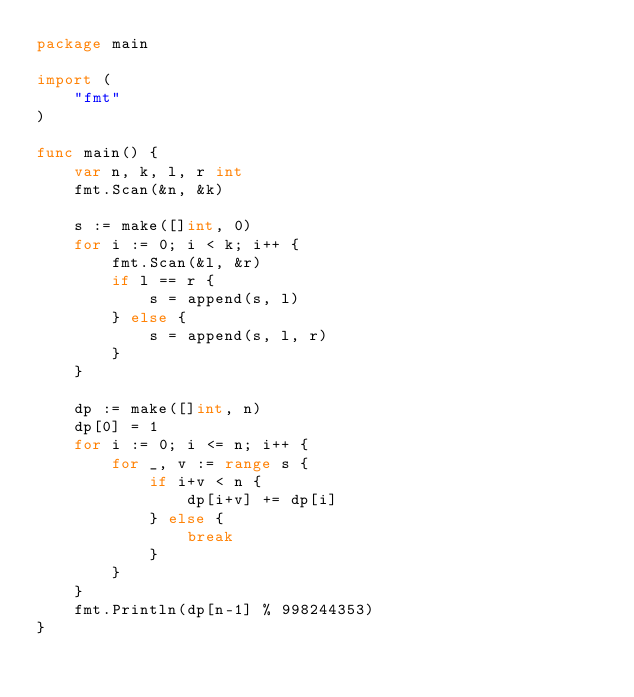Convert code to text. <code><loc_0><loc_0><loc_500><loc_500><_Go_>package main

import (
	"fmt"
)

func main() {
	var n, k, l, r int
	fmt.Scan(&n, &k)

	s := make([]int, 0)
	for i := 0; i < k; i++ {
		fmt.Scan(&l, &r)
		if l == r {
			s = append(s, l)
		} else {
			s = append(s, l, r)
		}
	}

	dp := make([]int, n)
	dp[0] = 1
	for i := 0; i <= n; i++ {
		for _, v := range s {
			if i+v < n {
				dp[i+v] += dp[i]
			} else {
				break
			}
		}
	}
	fmt.Println(dp[n-1] % 998244353)
}
</code> 